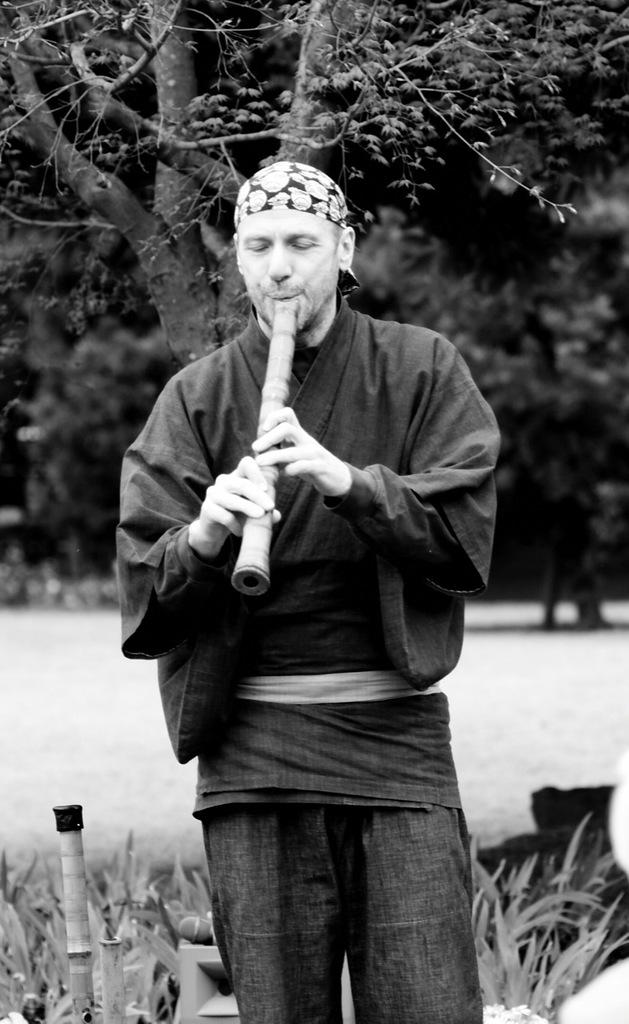What is the man in the image doing? The man is playing a musical instrument in the image. What can be seen in the background of the image? There are trees and plants in the background of the image. What type of linen is being used as a backdrop for the man's performance in the image? There is no linen present in the image; it is a man playing a musical instrument with trees and plants in the background. 